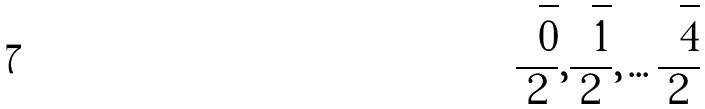<formula> <loc_0><loc_0><loc_500><loc_500>\frac { \sqrt { 0 } } { 2 } , \frac { \sqrt { 1 } } { 2 } , \dots \frac { \sqrt { 4 } } { 2 }</formula> 